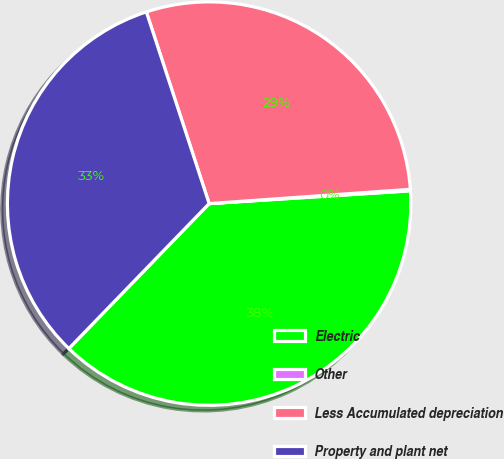<chart> <loc_0><loc_0><loc_500><loc_500><pie_chart><fcel>Electric<fcel>Other<fcel>Less Accumulated depreciation<fcel>Property and plant net<nl><fcel>38.25%<fcel>0.12%<fcel>28.91%<fcel>32.72%<nl></chart> 